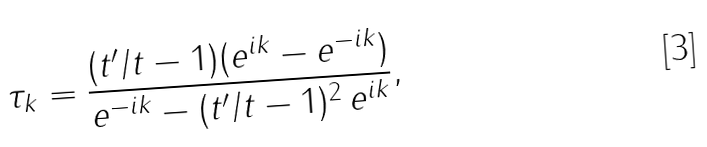<formula> <loc_0><loc_0><loc_500><loc_500>\tau _ { k } = \frac { ( t ^ { \prime } / t - 1 ) ( e ^ { i k } - e ^ { - i k } ) } { e ^ { - i k } - ( t ^ { \prime } / t - 1 ) ^ { 2 } \, e ^ { i k } } ,</formula> 